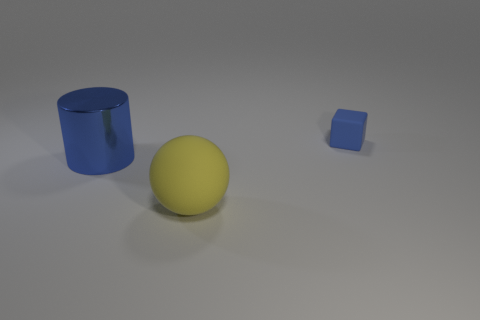Are there any other things that have the same size as the matte block?
Keep it short and to the point. No. What number of large objects are gray spheres or rubber objects?
Keep it short and to the point. 1. Is there any other thing that is the same shape as the small thing?
Make the answer very short. No. What is the color of the object that is made of the same material as the small cube?
Your answer should be compact. Yellow. What color is the rubber thing that is to the left of the tiny blue object?
Provide a succinct answer. Yellow. How many other small rubber cubes have the same color as the block?
Your answer should be compact. 0. Is the number of big things in front of the yellow matte sphere less than the number of big yellow objects that are to the right of the tiny matte cube?
Your answer should be compact. No. How many blue matte cubes are on the left side of the big rubber thing?
Make the answer very short. 0. Is there a blue object that has the same material as the ball?
Offer a very short reply. Yes. Are there more small things behind the blue cube than blue metallic cylinders in front of the large yellow rubber thing?
Provide a succinct answer. No. 